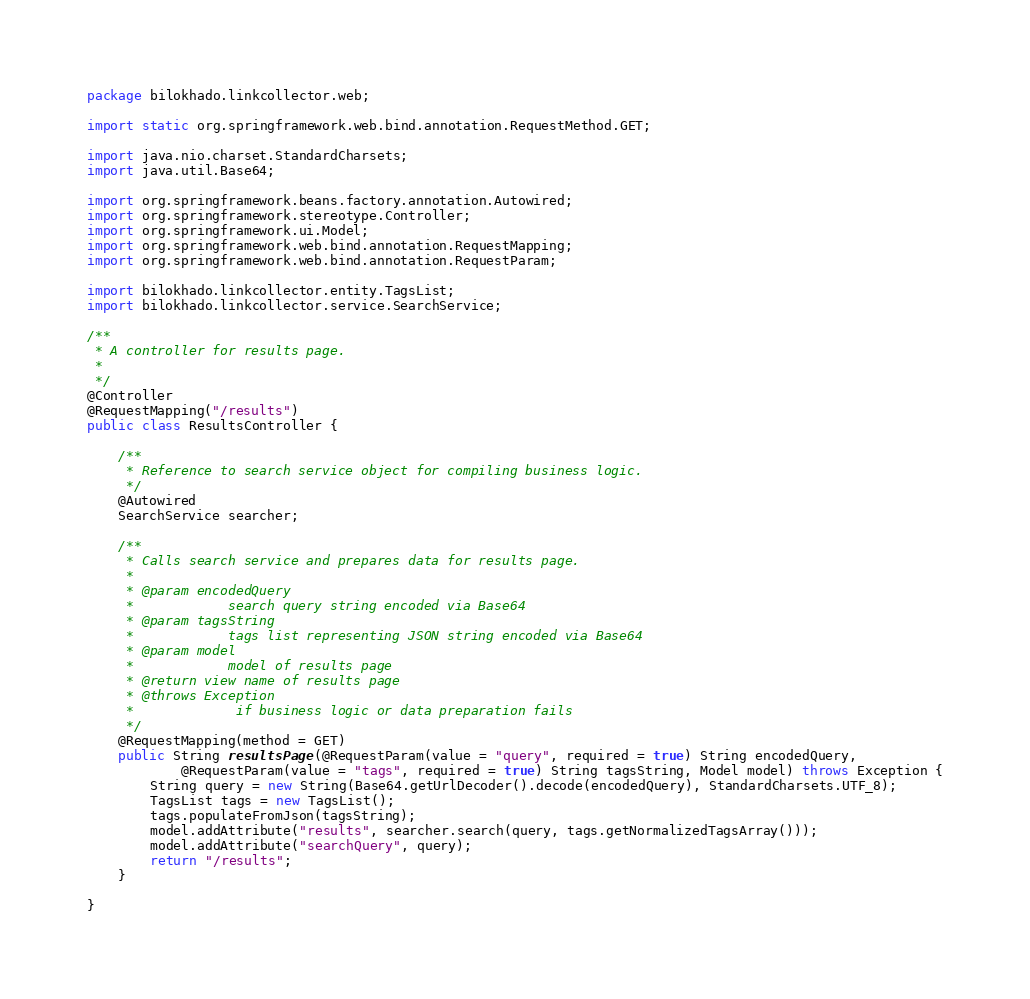<code> <loc_0><loc_0><loc_500><loc_500><_Java_>package bilokhado.linkcollector.web;

import static org.springframework.web.bind.annotation.RequestMethod.GET;

import java.nio.charset.StandardCharsets;
import java.util.Base64;

import org.springframework.beans.factory.annotation.Autowired;
import org.springframework.stereotype.Controller;
import org.springframework.ui.Model;
import org.springframework.web.bind.annotation.RequestMapping;
import org.springframework.web.bind.annotation.RequestParam;

import bilokhado.linkcollector.entity.TagsList;
import bilokhado.linkcollector.service.SearchService;

/**
 * A controller for results page.
 *
 */
@Controller
@RequestMapping("/results")
public class ResultsController {

	/**
	 * Reference to search service object for compiling business logic.
	 */
	@Autowired
	SearchService searcher;

	/**
	 * Calls search service and prepares data for results page.
	 * 
	 * @param encodedQuery
	 *            search query string encoded via Base64
	 * @param tagsString
	 *            tags list representing JSON string encoded via Base64
	 * @param model
	 *            model of results page
	 * @return view name of results page
	 * @throws Exception
	 *             if business logic or data preparation fails
	 */
	@RequestMapping(method = GET)
	public String resultsPage(@RequestParam(value = "query", required = true) String encodedQuery,
			@RequestParam(value = "tags", required = true) String tagsString, Model model) throws Exception {
		String query = new String(Base64.getUrlDecoder().decode(encodedQuery), StandardCharsets.UTF_8);
		TagsList tags = new TagsList();
		tags.populateFromJson(tagsString);
		model.addAttribute("results", searcher.search(query, tags.getNormalizedTagsArray()));
		model.addAttribute("searchQuery", query);
		return "/results";
	}

}
</code> 